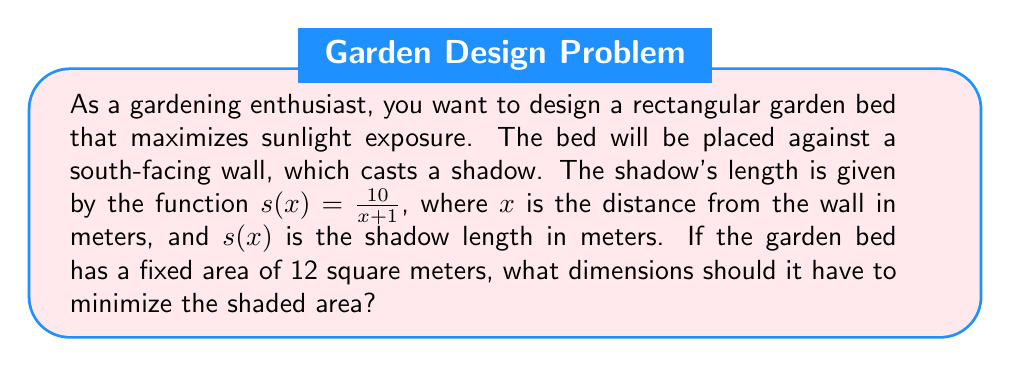Help me with this question. Let's approach this step-by-step:

1) Let the width of the bed (distance from the wall) be $x$ meters and the length be $y$ meters.

2) Given the area is fixed at 12 square meters, we can express $y$ in terms of $x$:
   $xy = 12$
   $y = \frac{12}{x}$

3) The shaded area is a function of $x$, let's call it $A(x)$:
   $A(x) = s(x) \cdot y = \frac{10}{x+1} \cdot \frac{12}{x} = \frac{120}{x(x+1)}$

4) To minimize $A(x)$, we need to find where its derivative equals zero:
   $$A'(x) = \frac{d}{dx}\left(\frac{120}{x(x+1)}\right) = -120 \cdot \frac{2x+1}{x^2(x+1)^2}$$

5) Set $A'(x) = 0$ and solve:
   $-120 \cdot \frac{2x+1}{x^2(x+1)^2} = 0$
   $2x+1 = 0$
   $x = -\frac{1}{2}$

6) Since $x$ can't be negative (it's a distance), this critical point is not in our domain. The minimum must occur at an endpoint.

7) Our domain is $(0,\infty)$, but practically, $x$ shouldn't be larger than 12 (as $y$ would be less than 1 meter).

8) Compare $A(0^+)$ and $A(12)$:
   $\lim_{x \to 0^+} A(x) = \infty$
   $A(12) = \frac{120}{12(13)} \approx 0.77$

9) The minimum occurs at $x=12$, so the optimal dimensions are:
   Width (x) = 12 meters
   Length (y) = 12/12 = 1 meter
Answer: 12 meters by 1 meter 